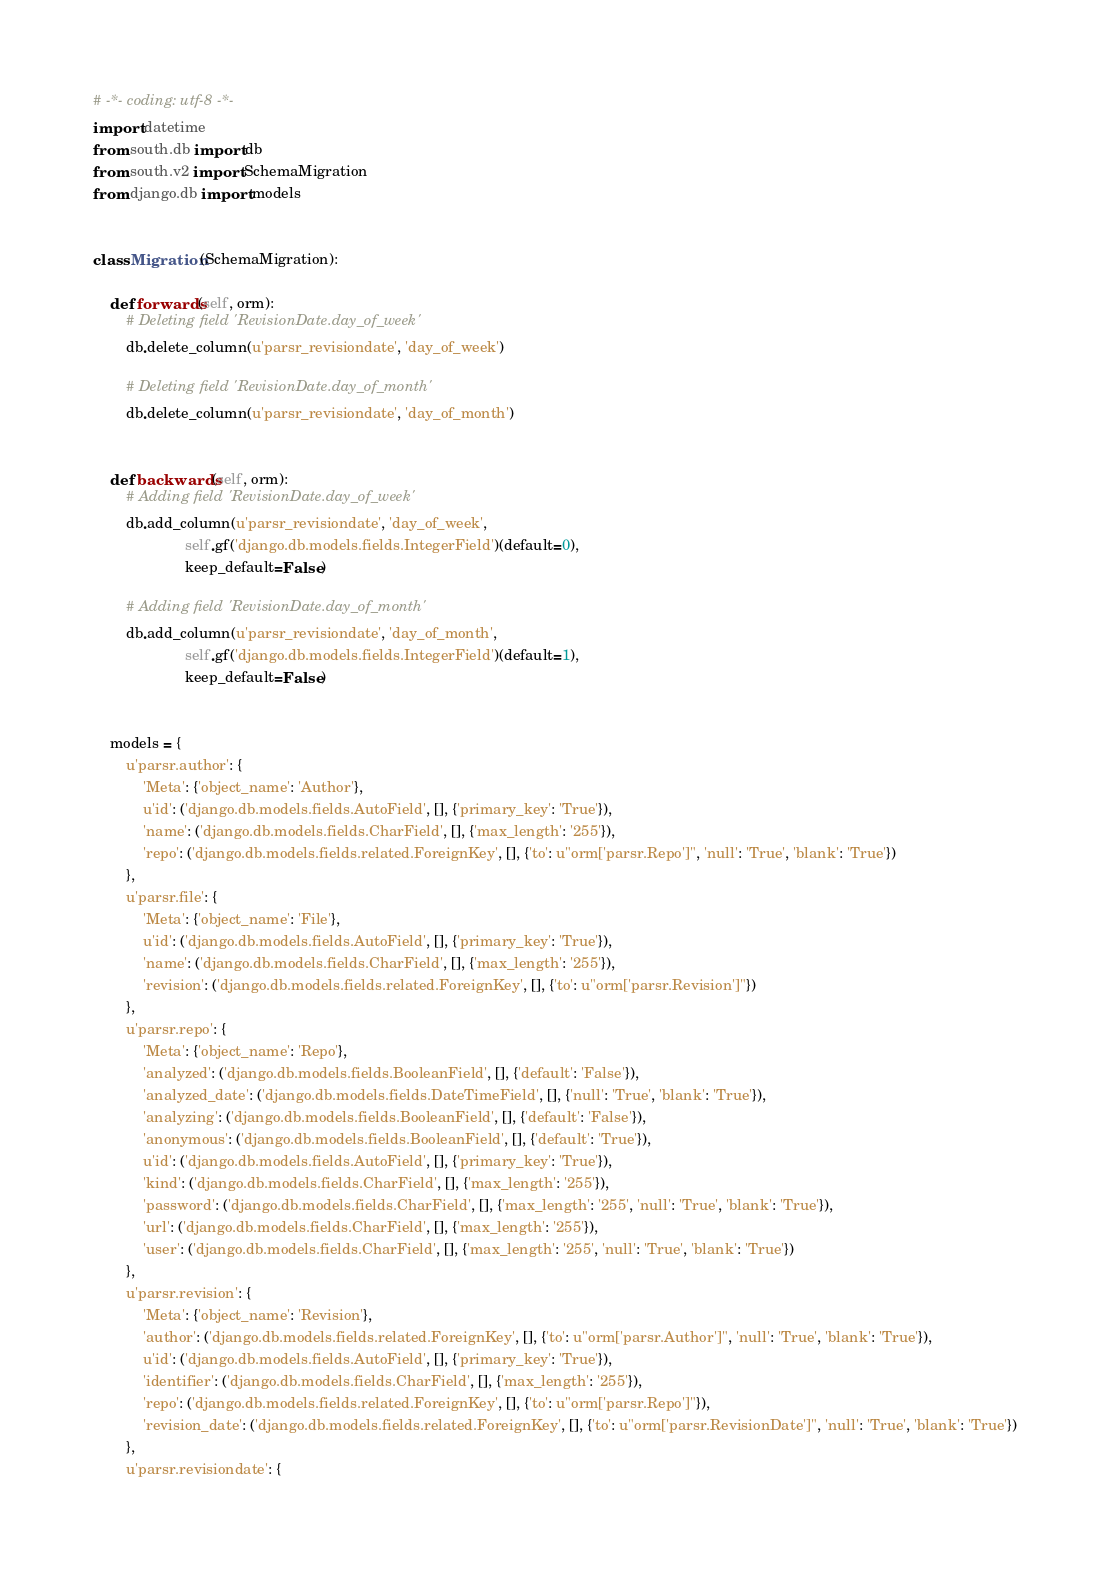Convert code to text. <code><loc_0><loc_0><loc_500><loc_500><_Python_># -*- coding: utf-8 -*-
import datetime
from south.db import db
from south.v2 import SchemaMigration
from django.db import models


class Migration(SchemaMigration):

    def forwards(self, orm):
        # Deleting field 'RevisionDate.day_of_week'
        db.delete_column(u'parsr_revisiondate', 'day_of_week')

        # Deleting field 'RevisionDate.day_of_month'
        db.delete_column(u'parsr_revisiondate', 'day_of_month')


    def backwards(self, orm):
        # Adding field 'RevisionDate.day_of_week'
        db.add_column(u'parsr_revisiondate', 'day_of_week',
                      self.gf('django.db.models.fields.IntegerField')(default=0),
                      keep_default=False)

        # Adding field 'RevisionDate.day_of_month'
        db.add_column(u'parsr_revisiondate', 'day_of_month',
                      self.gf('django.db.models.fields.IntegerField')(default=1),
                      keep_default=False)


    models = {
        u'parsr.author': {
            'Meta': {'object_name': 'Author'},
            u'id': ('django.db.models.fields.AutoField', [], {'primary_key': 'True'}),
            'name': ('django.db.models.fields.CharField', [], {'max_length': '255'}),
            'repo': ('django.db.models.fields.related.ForeignKey', [], {'to': u"orm['parsr.Repo']", 'null': 'True', 'blank': 'True'})
        },
        u'parsr.file': {
            'Meta': {'object_name': 'File'},
            u'id': ('django.db.models.fields.AutoField', [], {'primary_key': 'True'}),
            'name': ('django.db.models.fields.CharField', [], {'max_length': '255'}),
            'revision': ('django.db.models.fields.related.ForeignKey', [], {'to': u"orm['parsr.Revision']"})
        },
        u'parsr.repo': {
            'Meta': {'object_name': 'Repo'},
            'analyzed': ('django.db.models.fields.BooleanField', [], {'default': 'False'}),
            'analyzed_date': ('django.db.models.fields.DateTimeField', [], {'null': 'True', 'blank': 'True'}),
            'analyzing': ('django.db.models.fields.BooleanField', [], {'default': 'False'}),
            'anonymous': ('django.db.models.fields.BooleanField', [], {'default': 'True'}),
            u'id': ('django.db.models.fields.AutoField', [], {'primary_key': 'True'}),
            'kind': ('django.db.models.fields.CharField', [], {'max_length': '255'}),
            'password': ('django.db.models.fields.CharField', [], {'max_length': '255', 'null': 'True', 'blank': 'True'}),
            'url': ('django.db.models.fields.CharField', [], {'max_length': '255'}),
            'user': ('django.db.models.fields.CharField', [], {'max_length': '255', 'null': 'True', 'blank': 'True'})
        },
        u'parsr.revision': {
            'Meta': {'object_name': 'Revision'},
            'author': ('django.db.models.fields.related.ForeignKey', [], {'to': u"orm['parsr.Author']", 'null': 'True', 'blank': 'True'}),
            u'id': ('django.db.models.fields.AutoField', [], {'primary_key': 'True'}),
            'identifier': ('django.db.models.fields.CharField', [], {'max_length': '255'}),
            'repo': ('django.db.models.fields.related.ForeignKey', [], {'to': u"orm['parsr.Repo']"}),
            'revision_date': ('django.db.models.fields.related.ForeignKey', [], {'to': u"orm['parsr.RevisionDate']", 'null': 'True', 'blank': 'True'})
        },
        u'parsr.revisiondate': {</code> 